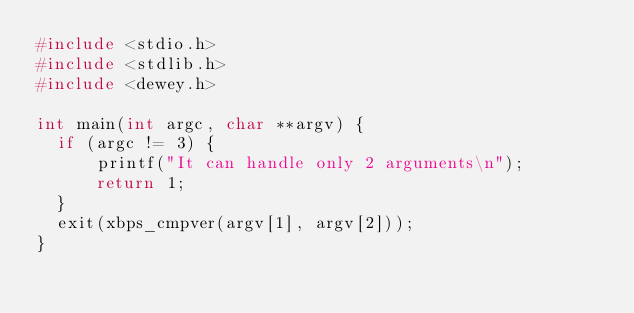Convert code to text. <code><loc_0><loc_0><loc_500><loc_500><_C_>#include <stdio.h>
#include <stdlib.h>
#include <dewey.h>

int main(int argc, char **argv) {
	if (argc != 3) {
			printf("It can handle only 2 arguments\n");
			return 1;
	}
	exit(xbps_cmpver(argv[1], argv[2]));
}
</code> 